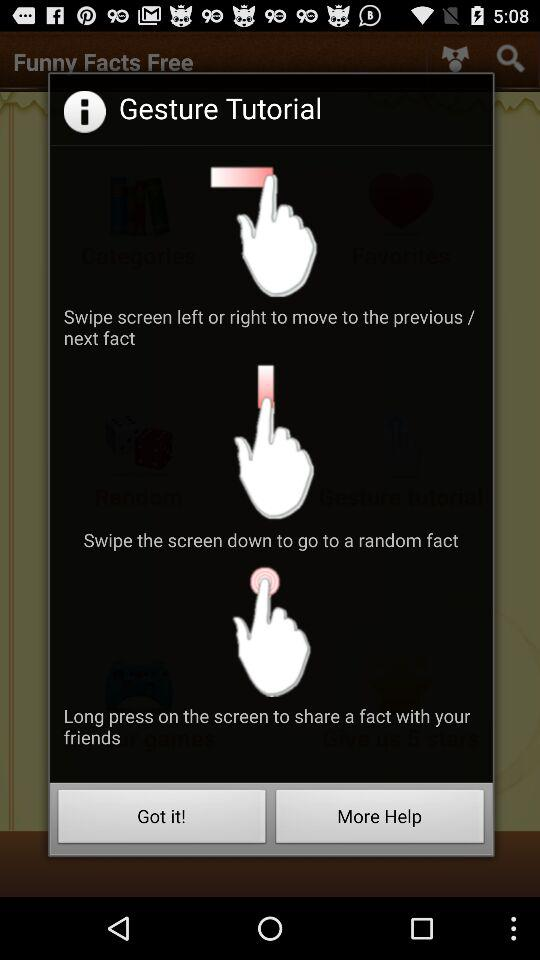What will happen when we swipe the screen left or right? By swiping left or right on the screen, you will move to the previous or next fact. 